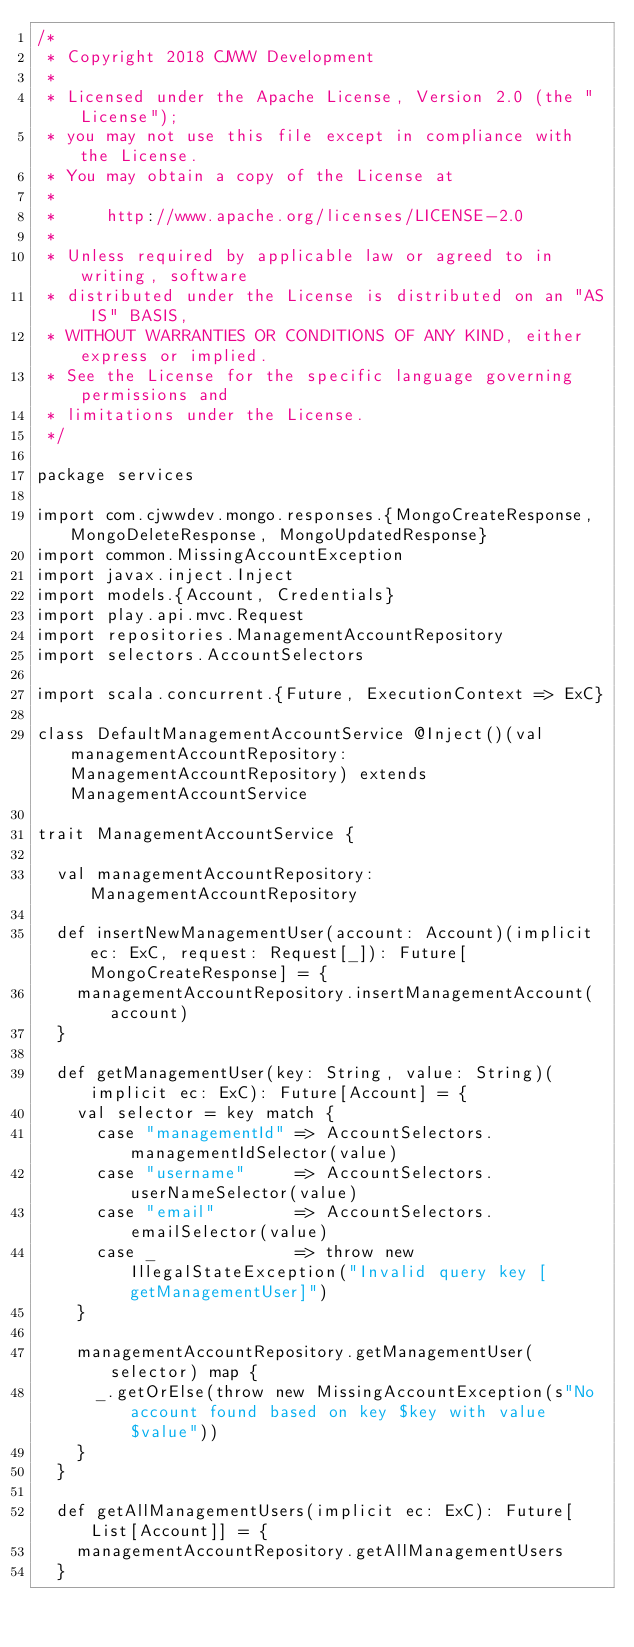<code> <loc_0><loc_0><loc_500><loc_500><_Scala_>/*
 * Copyright 2018 CJWW Development
 *
 * Licensed under the Apache License, Version 2.0 (the "License");
 * you may not use this file except in compliance with the License.
 * You may obtain a copy of the License at
 *
 *     http://www.apache.org/licenses/LICENSE-2.0
 *
 * Unless required by applicable law or agreed to in writing, software
 * distributed under the License is distributed on an "AS IS" BASIS,
 * WITHOUT WARRANTIES OR CONDITIONS OF ANY KIND, either express or implied.
 * See the License for the specific language governing permissions and
 * limitations under the License.
 */

package services

import com.cjwwdev.mongo.responses.{MongoCreateResponse, MongoDeleteResponse, MongoUpdatedResponse}
import common.MissingAccountException
import javax.inject.Inject
import models.{Account, Credentials}
import play.api.mvc.Request
import repositories.ManagementAccountRepository
import selectors.AccountSelectors

import scala.concurrent.{Future, ExecutionContext => ExC}

class DefaultManagementAccountService @Inject()(val managementAccountRepository: ManagementAccountRepository) extends ManagementAccountService

trait ManagementAccountService {

  val managementAccountRepository: ManagementAccountRepository

  def insertNewManagementUser(account: Account)(implicit ec: ExC, request: Request[_]): Future[MongoCreateResponse] = {
    managementAccountRepository.insertManagementAccount(account)
  }

  def getManagementUser(key: String, value: String)(implicit ec: ExC): Future[Account] = {
    val selector = key match {
      case "managementId" => AccountSelectors.managementIdSelector(value)
      case "username"     => AccountSelectors.userNameSelector(value)
      case "email"        => AccountSelectors.emailSelector(value)
      case _              => throw new IllegalStateException("Invalid query key [getManagementUser]")
    }

    managementAccountRepository.getManagementUser(selector) map {
      _.getOrElse(throw new MissingAccountException(s"No account found based on key $key with value $value"))
    }
  }

  def getAllManagementUsers(implicit ec: ExC): Future[List[Account]] = {
    managementAccountRepository.getAllManagementUsers
  }
</code> 